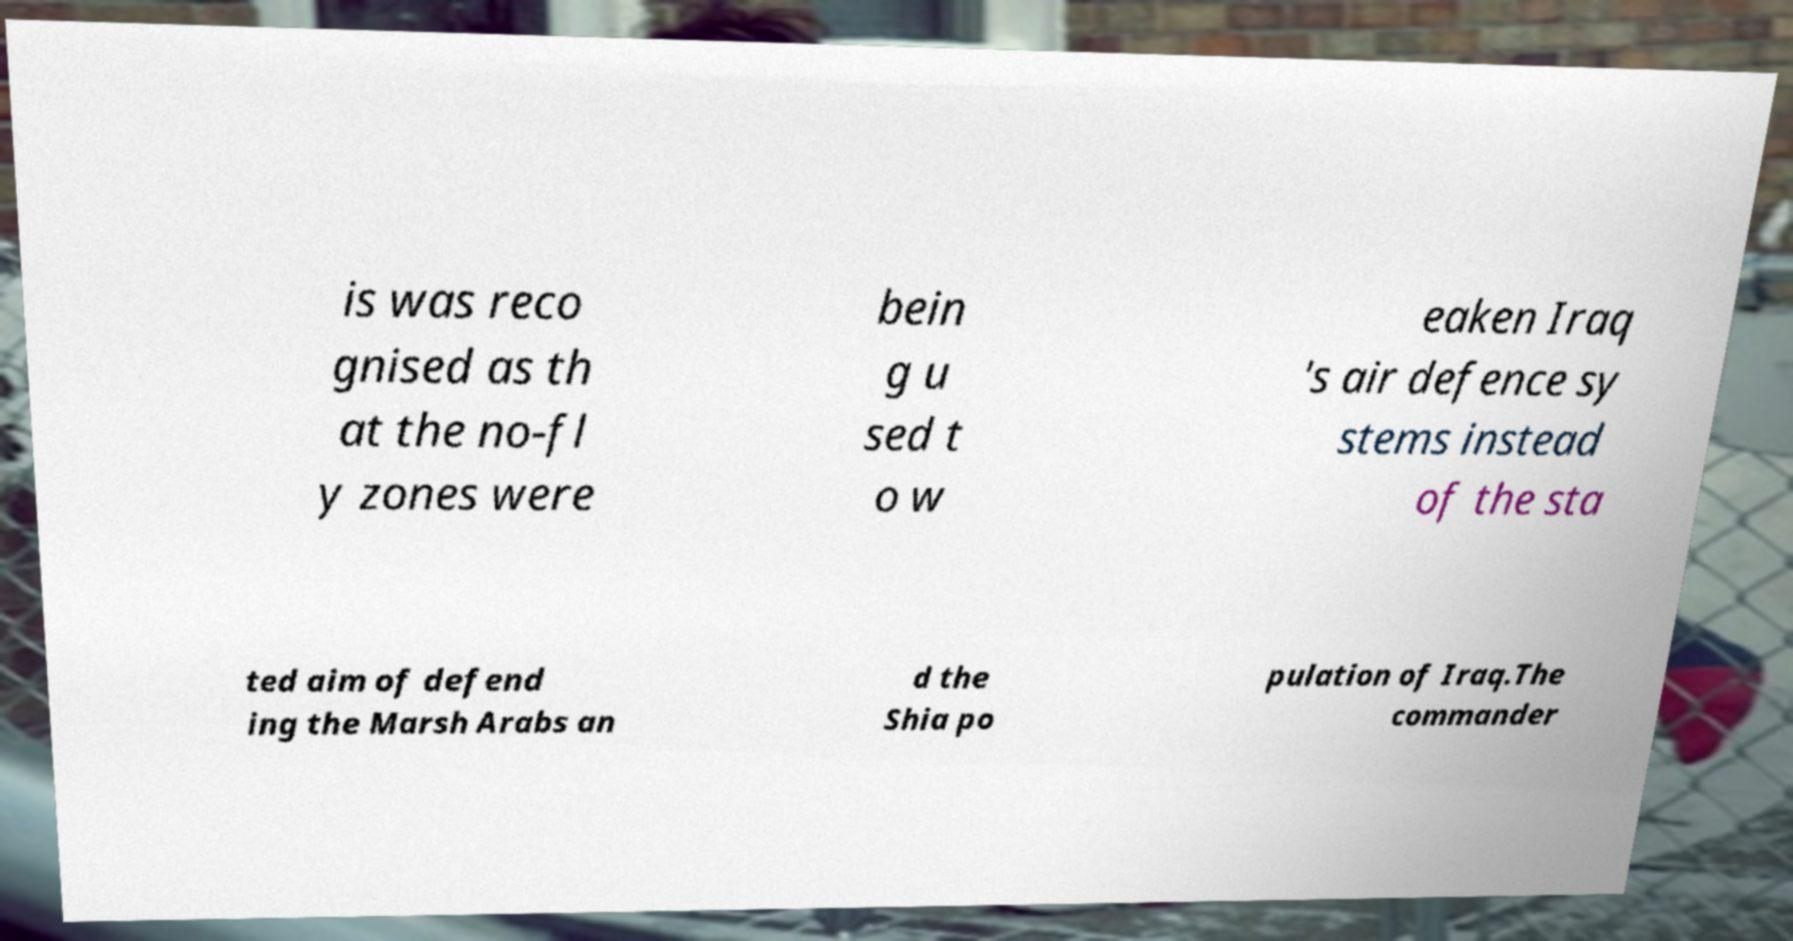What messages or text are displayed in this image? I need them in a readable, typed format. is was reco gnised as th at the no-fl y zones were bein g u sed t o w eaken Iraq 's air defence sy stems instead of the sta ted aim of defend ing the Marsh Arabs an d the Shia po pulation of Iraq.The commander 